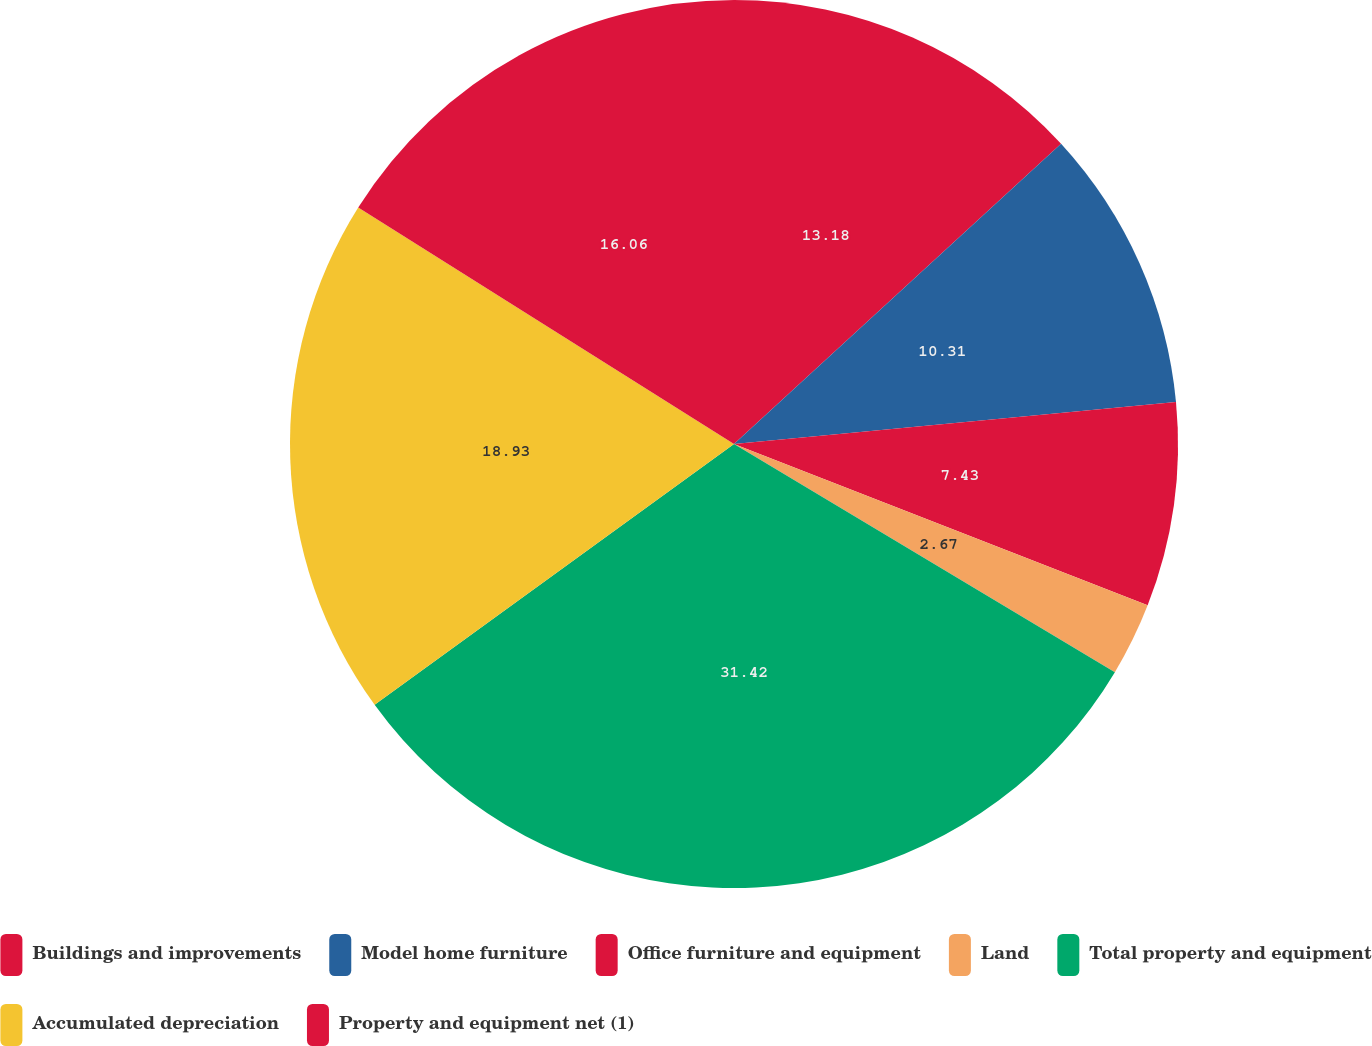<chart> <loc_0><loc_0><loc_500><loc_500><pie_chart><fcel>Buildings and improvements<fcel>Model home furniture<fcel>Office furniture and equipment<fcel>Land<fcel>Total property and equipment<fcel>Accumulated depreciation<fcel>Property and equipment net (1)<nl><fcel>13.18%<fcel>10.31%<fcel>7.43%<fcel>2.67%<fcel>31.42%<fcel>18.93%<fcel>16.06%<nl></chart> 